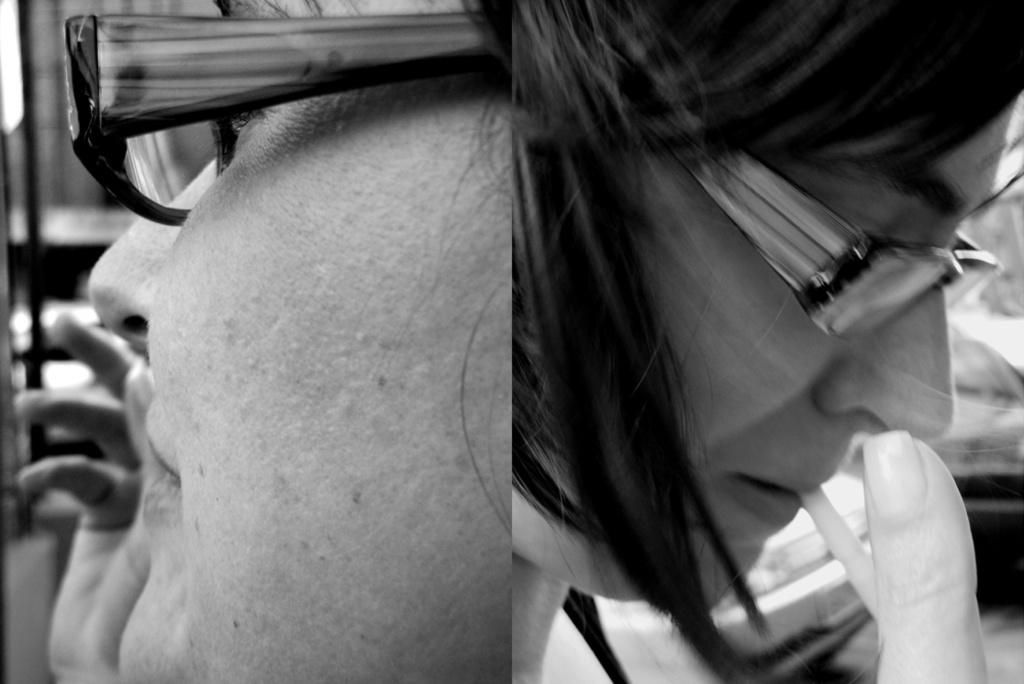What type of image is shown in the collage? The image is a black and white collage. How many people are present in the image? There are two persons in the image. What are the people wearing? Both persons are wearing spectacles. What can be seen in the background of the image? There are vehicles and other objects in the background of the image. How many cows are visible in the image? There are no cows present in the image; it is a collage featuring two people wearing spectacles. What type of potato is being used as a prop in the image? There is no potato present in the image. 